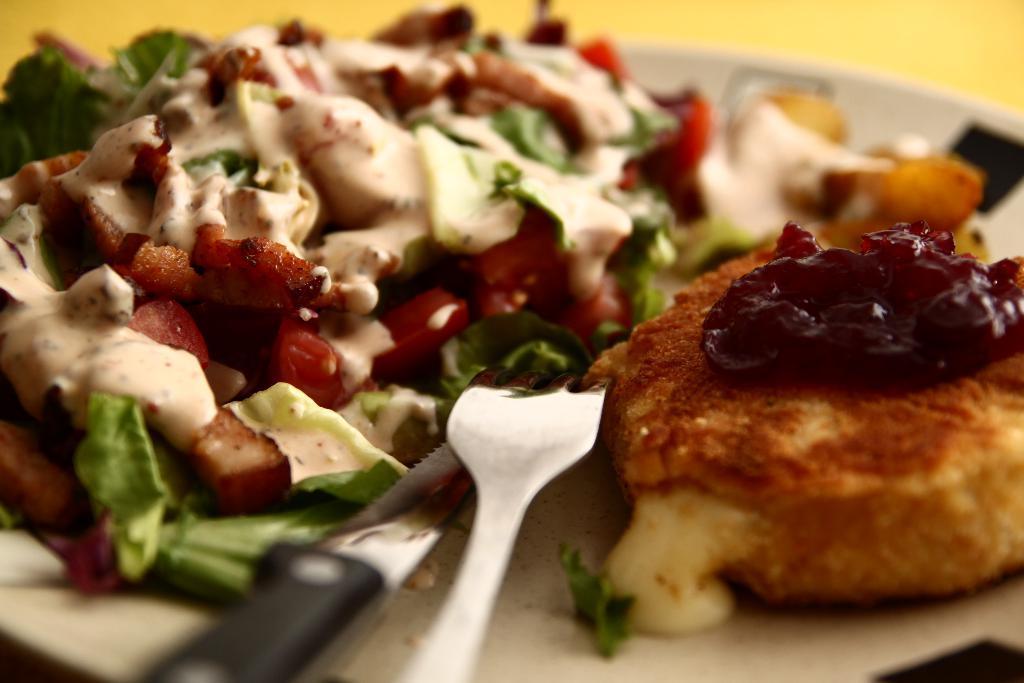Could you give a brief overview of what you see in this image? In this picture there is a plate in the center of the image, which contains food items and a knife and a fork in it. 